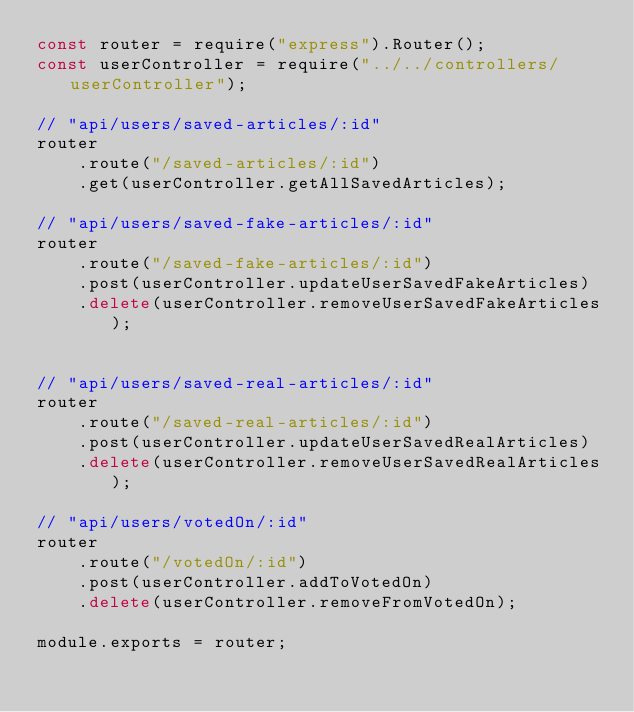<code> <loc_0><loc_0><loc_500><loc_500><_JavaScript_>const router = require("express").Router();
const userController = require("../../controllers/userController");

// "api/users/saved-articles/:id"
router
    .route("/saved-articles/:id")
    .get(userController.getAllSavedArticles);

// "api/users/saved-fake-articles/:id"
router
    .route("/saved-fake-articles/:id")
    .post(userController.updateUserSavedFakeArticles)
    .delete(userController.removeUserSavedFakeArticles);


// "api/users/saved-real-articles/:id"
router 
    .route("/saved-real-articles/:id")
    .post(userController.updateUserSavedRealArticles)
    .delete(userController.removeUserSavedRealArticles);

// "api/users/votedOn/:id"
router
    .route("/votedOn/:id")
    .post(userController.addToVotedOn)
    .delete(userController.removeFromVotedOn);

module.exports = router;

</code> 